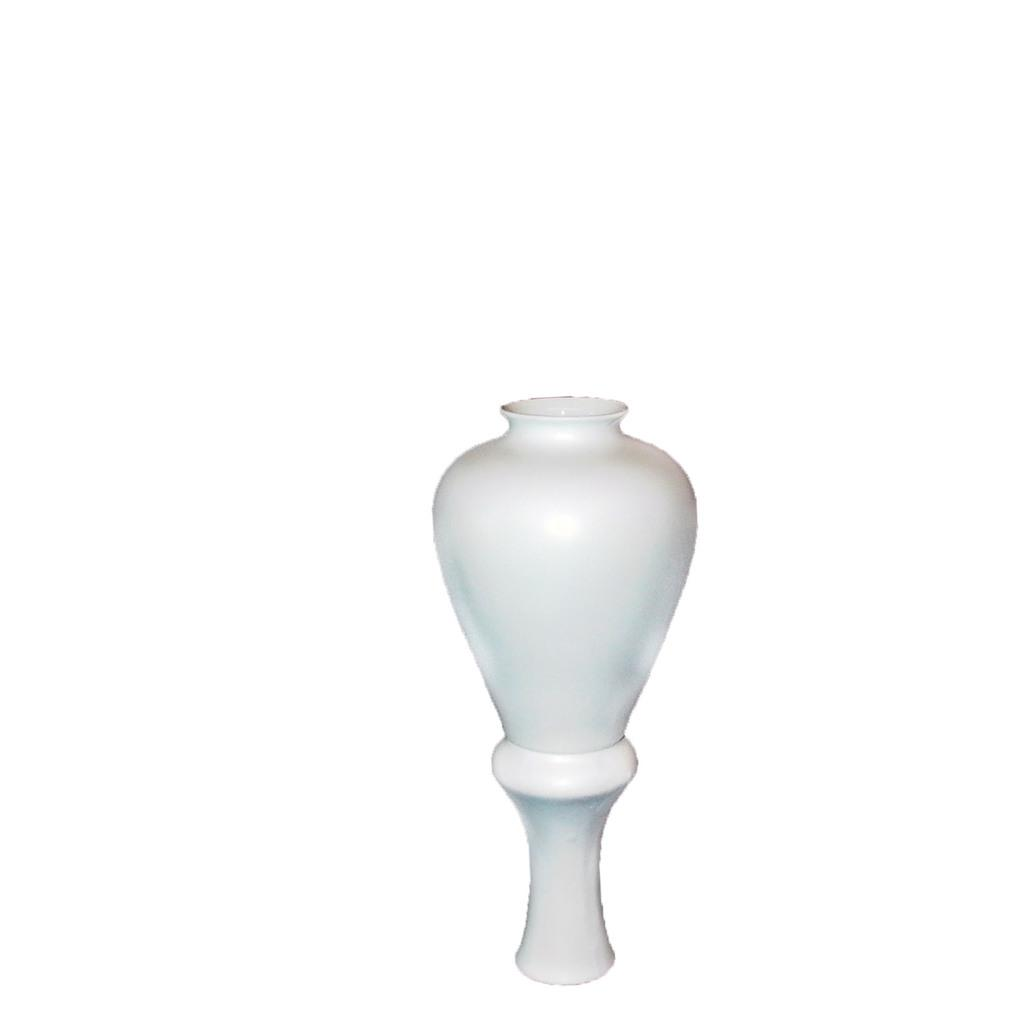What color is the object in the image? The object in the image is white. How many dogs are present in the image? There are no dogs present in the image; it only features a white color object. What type of laborer can be seen working in the image? There is no laborer present in the image; it only features a white color object. 